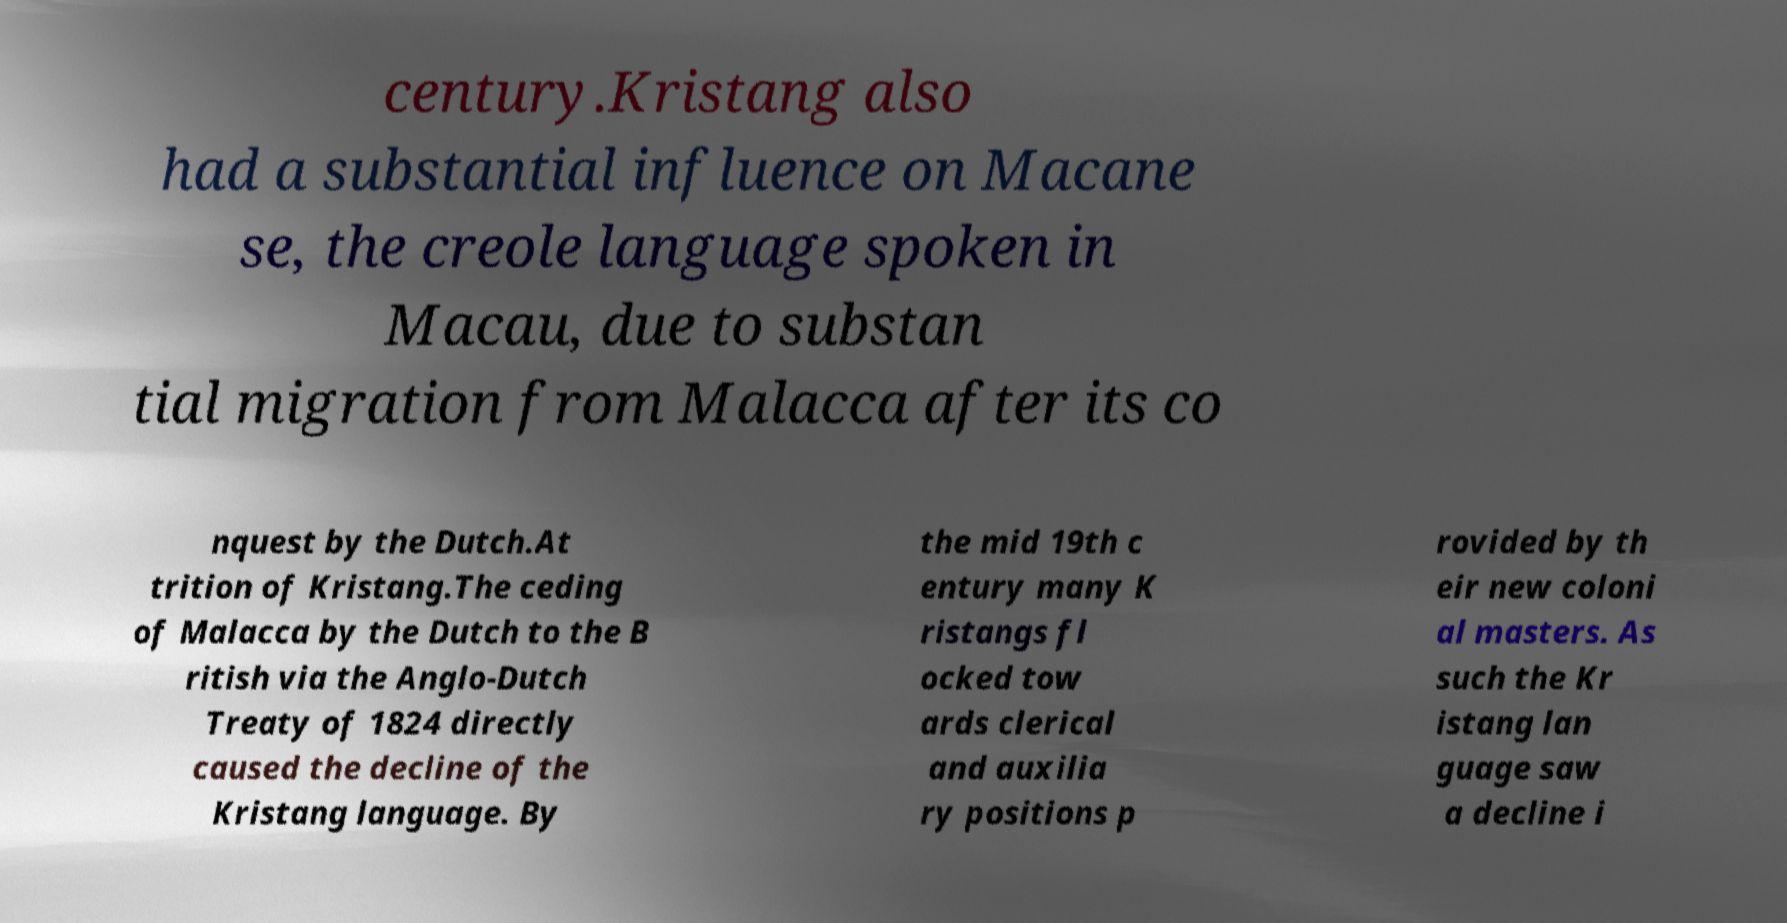Could you extract and type out the text from this image? century.Kristang also had a substantial influence on Macane se, the creole language spoken in Macau, due to substan tial migration from Malacca after its co nquest by the Dutch.At trition of Kristang.The ceding of Malacca by the Dutch to the B ritish via the Anglo-Dutch Treaty of 1824 directly caused the decline of the Kristang language. By the mid 19th c entury many K ristangs fl ocked tow ards clerical and auxilia ry positions p rovided by th eir new coloni al masters. As such the Kr istang lan guage saw a decline i 